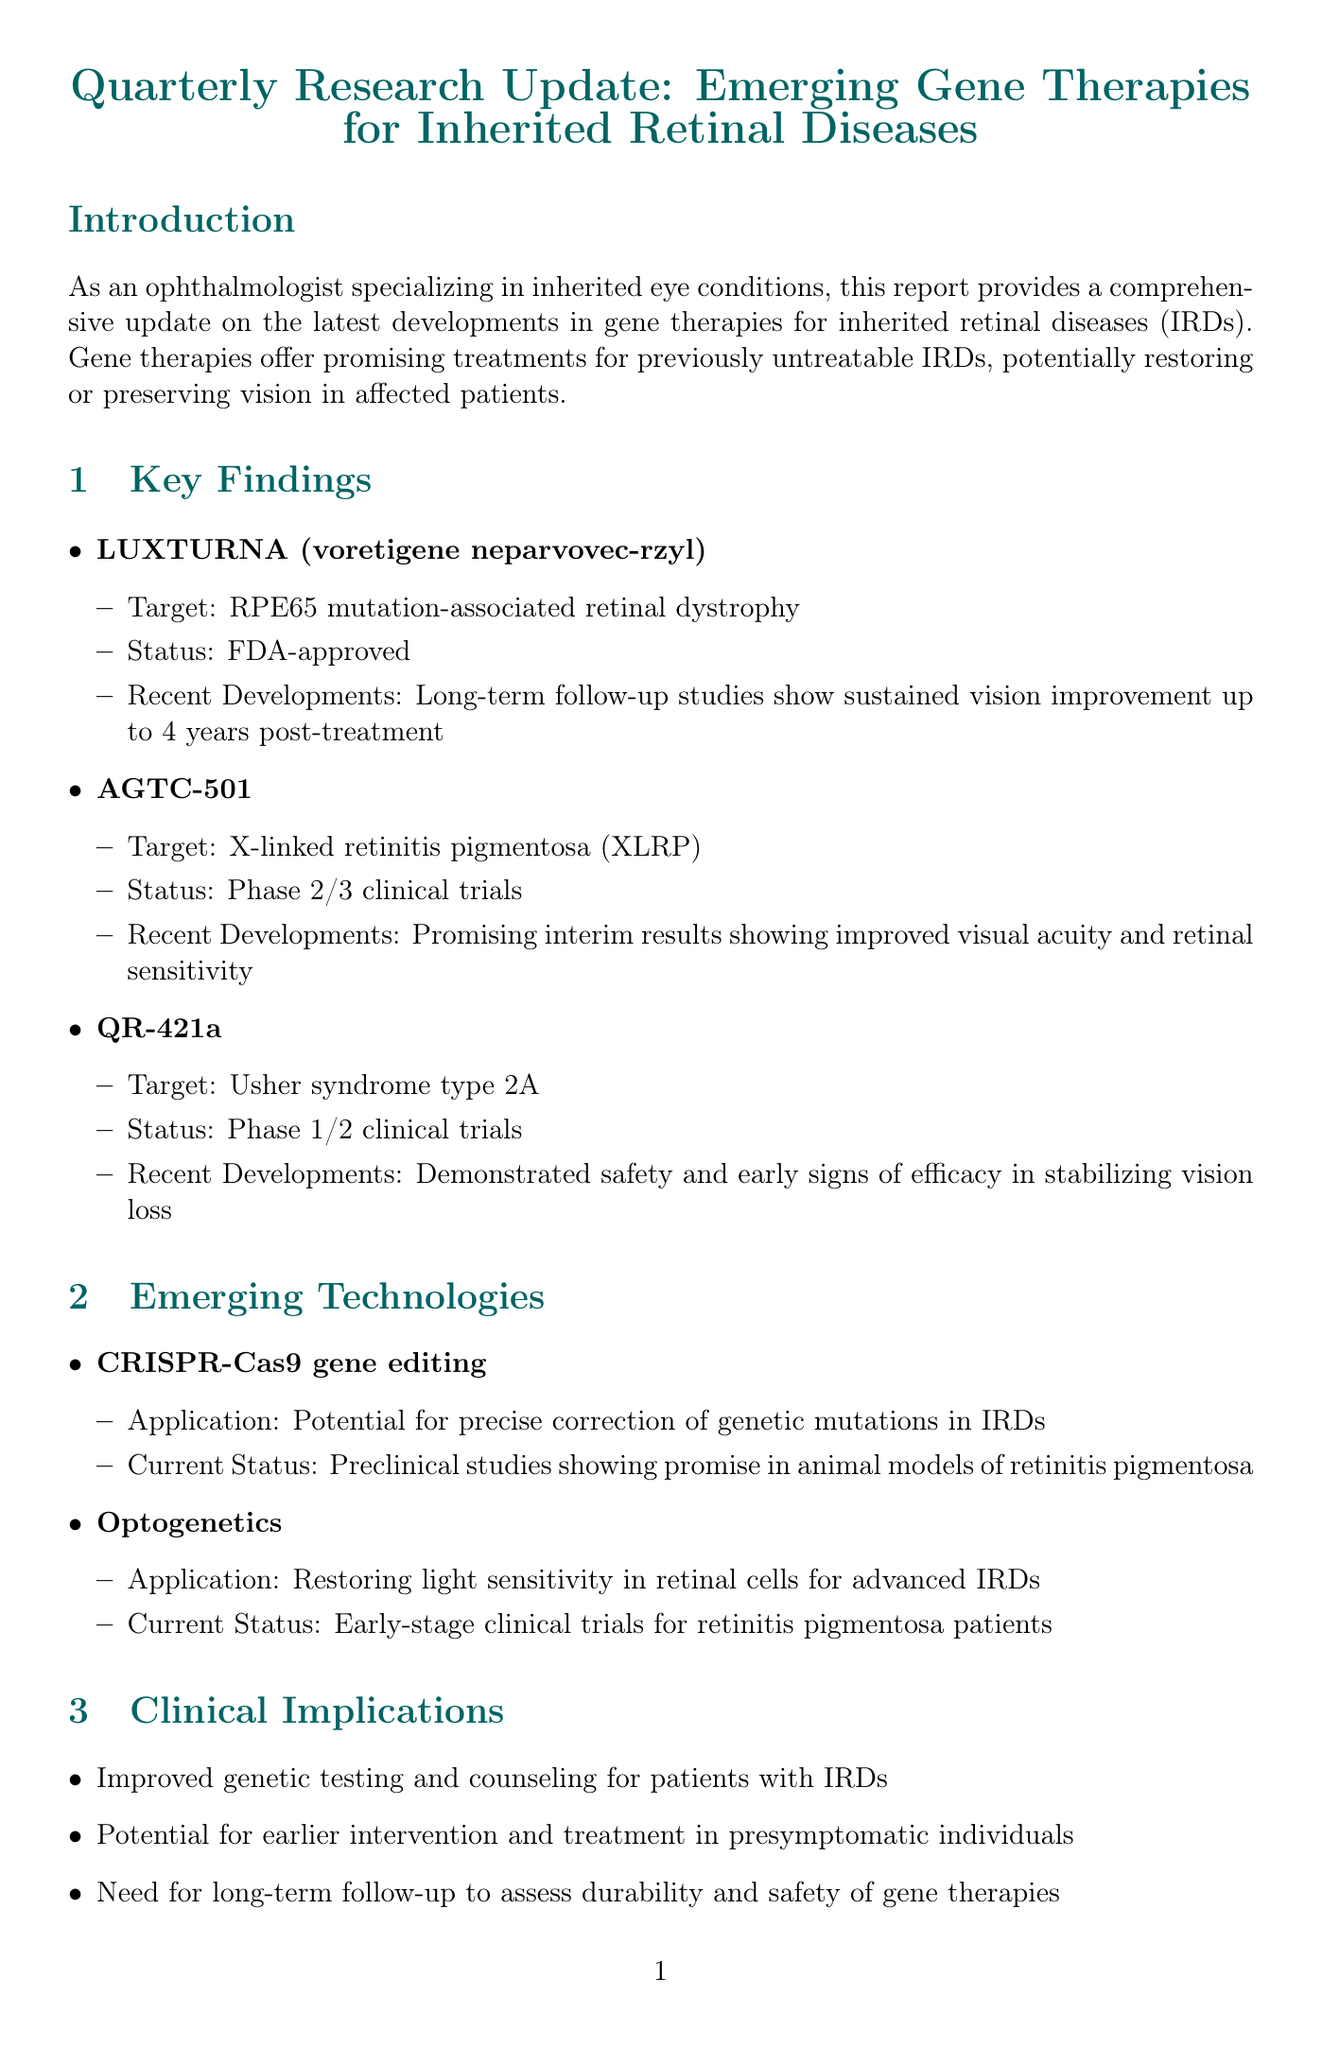What is the title of the report? The title of the report is explicitly stated at the beginning of the document.
Answer: Quarterly Research Update: Emerging Gene Therapies for Inherited Retinal Diseases What is the status of LUXTURNA? The status of LUXTURNA is listed under key findings within the report.
Answer: FDA-approved Which mutation is associated with AGTC-501? The specific mutation related to AGTC-501 is mentioned in the key findings section of the report.
Answer: X-linked retinitis pigmentosa (XLRP) What are the recent developments for QR-421a? Recent developments are detailed under key findings for QR-421a in the report.
Answer: Demonstrated safety and early signs of efficacy in stabilizing vision loss What is the application of CRISPR-Cas9 gene editing? The application of CRISPR-Cas9 is found in the emerging technologies section.
Answer: Potential for precise correction of genetic mutations in IRDs What is a challenge mentioned in the report? Challenges are outlined in a specific section of the report, detailing various obstacles in gene therapy.
Answer: High cost of gene therapies limiting accessibility What date is the American Academy of Ophthalmology Annual Meeting scheduled for? The date of the conference is listed in the upcoming conferences section.
Answer: November 3-6, 2023 Which journal published the key publication by Russell et al.? The specific journal for this publication can be found in the key publications section of the report.
Answer: Ophthalmology What is a potential future direction mentioned for gene therapies? Potential future directions are discussed in its designated section in the report.
Answer: Combination therapies using gene replacement and cell regeneration approaches 